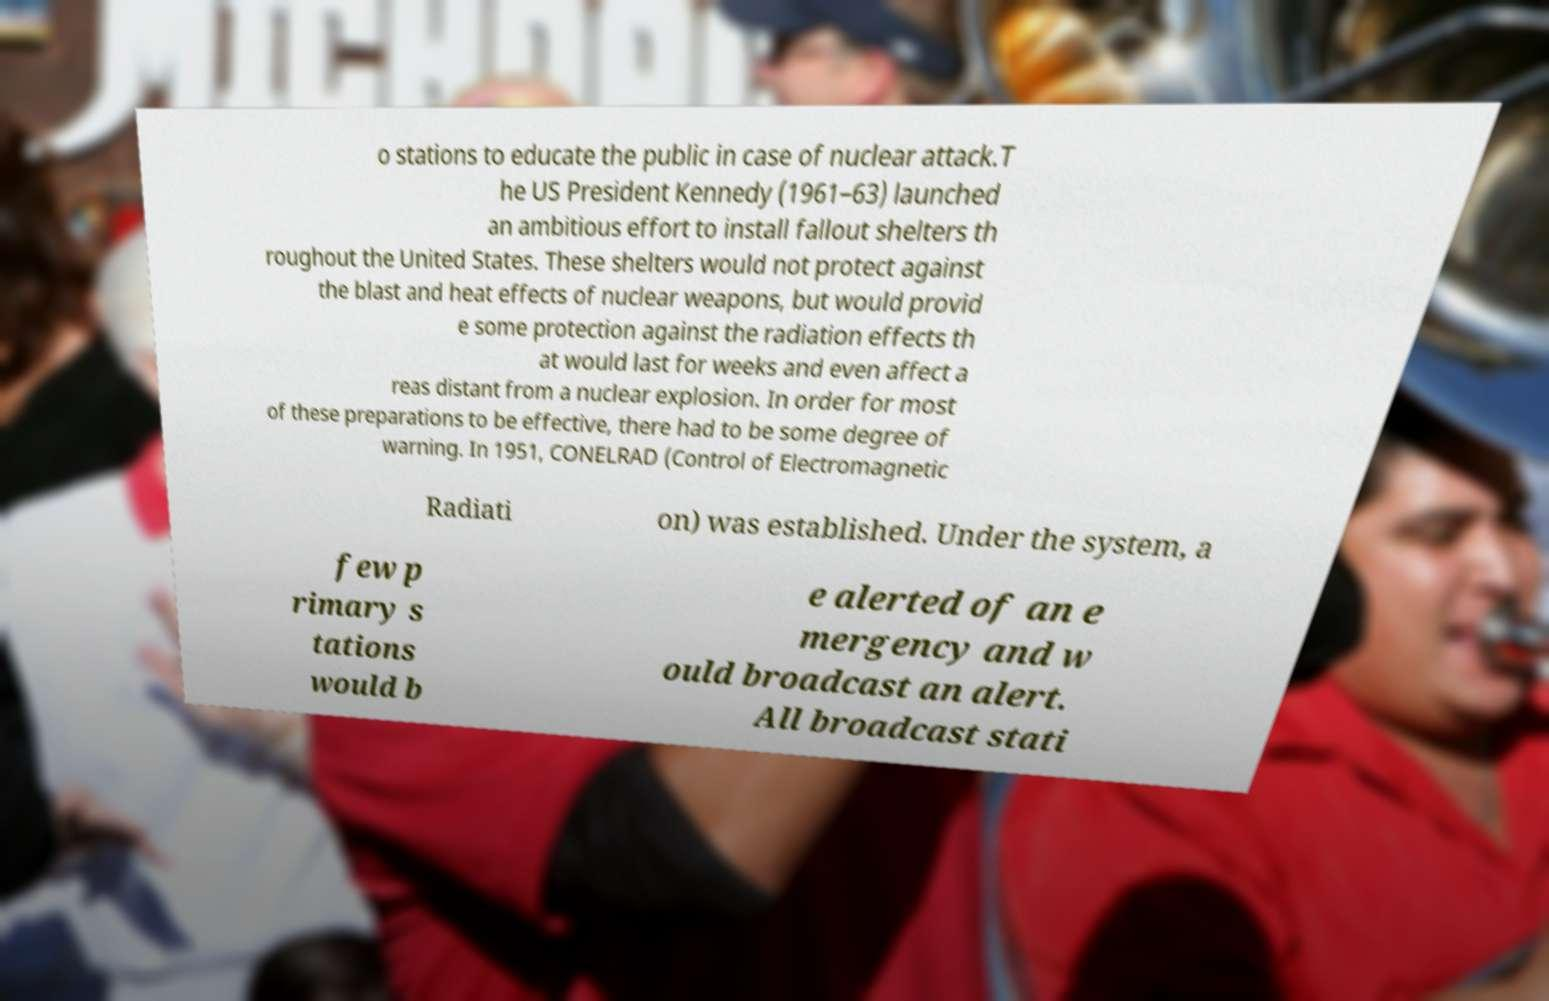Can you accurately transcribe the text from the provided image for me? o stations to educate the public in case of nuclear attack.T he US President Kennedy (1961–63) launched an ambitious effort to install fallout shelters th roughout the United States. These shelters would not protect against the blast and heat effects of nuclear weapons, but would provid e some protection against the radiation effects th at would last for weeks and even affect a reas distant from a nuclear explosion. In order for most of these preparations to be effective, there had to be some degree of warning. In 1951, CONELRAD (Control of Electromagnetic Radiati on) was established. Under the system, a few p rimary s tations would b e alerted of an e mergency and w ould broadcast an alert. All broadcast stati 